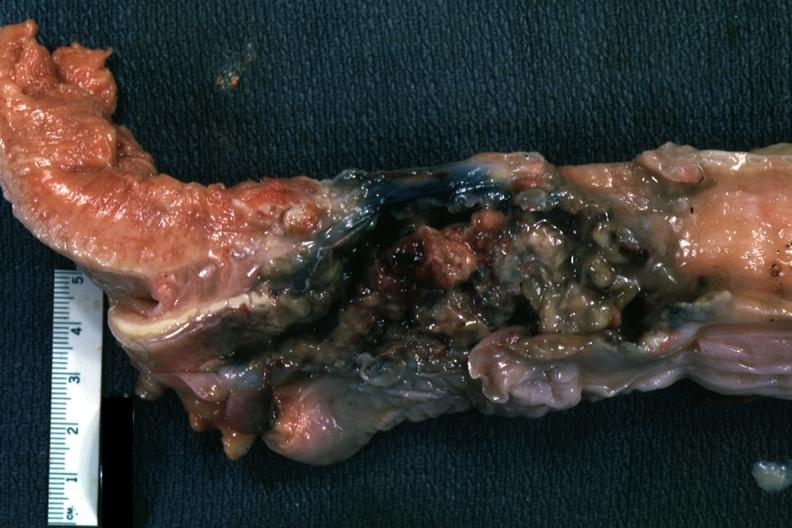what is present?
Answer the question using a single word or phrase. Oral 